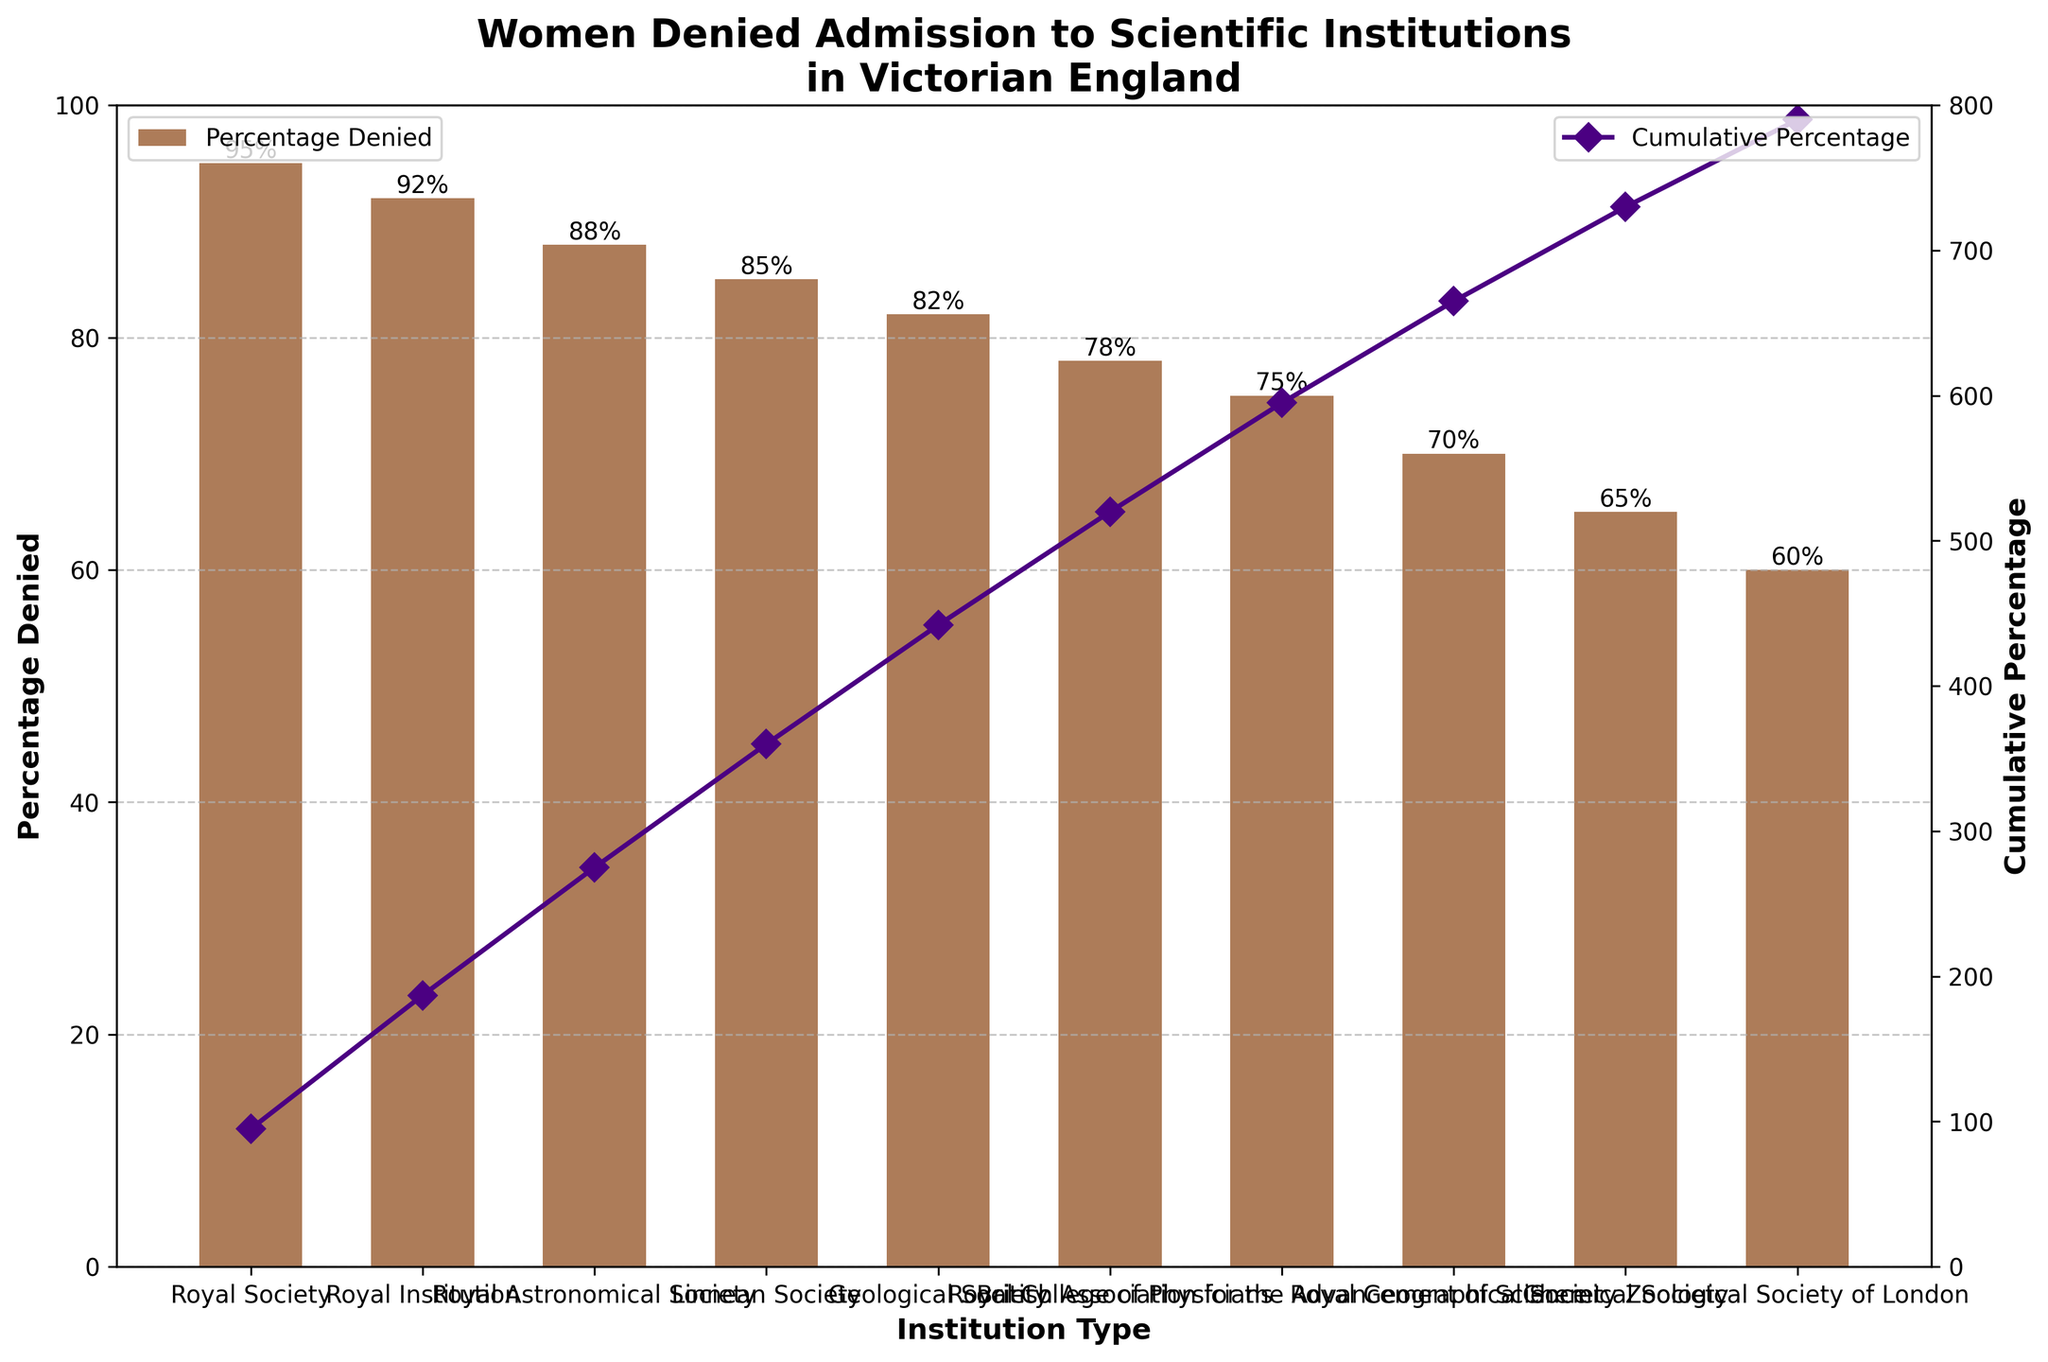What is the title of the figure? The title is at the top of the figure in a larger font, and it reads: "Women Denied Admission to Scientific Institutions in Victorian England"
Answer: Women Denied Admission to Scientific Institutions in Victorian England How is the percentage denied represented visually in the chart? The percentage denied is represented by the height of the bars. Each institution type has a corresponding bar with a height reflecting the percentage of women denied admission.
Answer: Height of the bars What is the cumulative percentage value for the Royal Institution? To find the cumulative percentage, look at the point on the cumulative percentage line corresponding to the Royal Institution. It is 187.
Answer: 187 Which institution has the highest percentage of women denied admission? Look at the bar heights; the highest bar represents the Royal Society with 95%.
Answer: Royal Society What is the difference in the percentage denied between the Geological Society and the Chemical Society? The Geological Society has 82%, and the Chemical Society has 65%. Subtract 65 from 82: 82 - 65 = 17.
Answer: 17 Which institution has the lowest percentage of women denied admission? Examine the shortest bar; the Zoological Society of London has the lowest percentage at 60%.
Answer: Zoological Society of London What’s the cumulative percentage after including the British Association for the Advancement of Science? The cumulative percentage for the British Association is represented on the cumulative line at that point, which is 595.
Answer: 595 How many institutions have a percentage denied of 85% or more? Look for bars with heights equal to or greater than 85%. Four institutions (Royal Society, Royal Institution, Royal Astronomical Society, Linnean Society) meet this criterion.
Answer: 4 What is the average percentage denied across all institutions? Add all the percentages denied and divide by the number of institutions: (95+92+88+85+82+78+75+70+65+60) / 10 = 79%.
Answer: 79% Between which two consecutive institutions is there the largest drop in the percentage denied? Compare the differences between consecutive bars: the largest drop is between the Geological Society (82%) and the Royal College of Physicians (78%), a drop of 4%.
Answer: Geological Society and Royal College of Physicians 